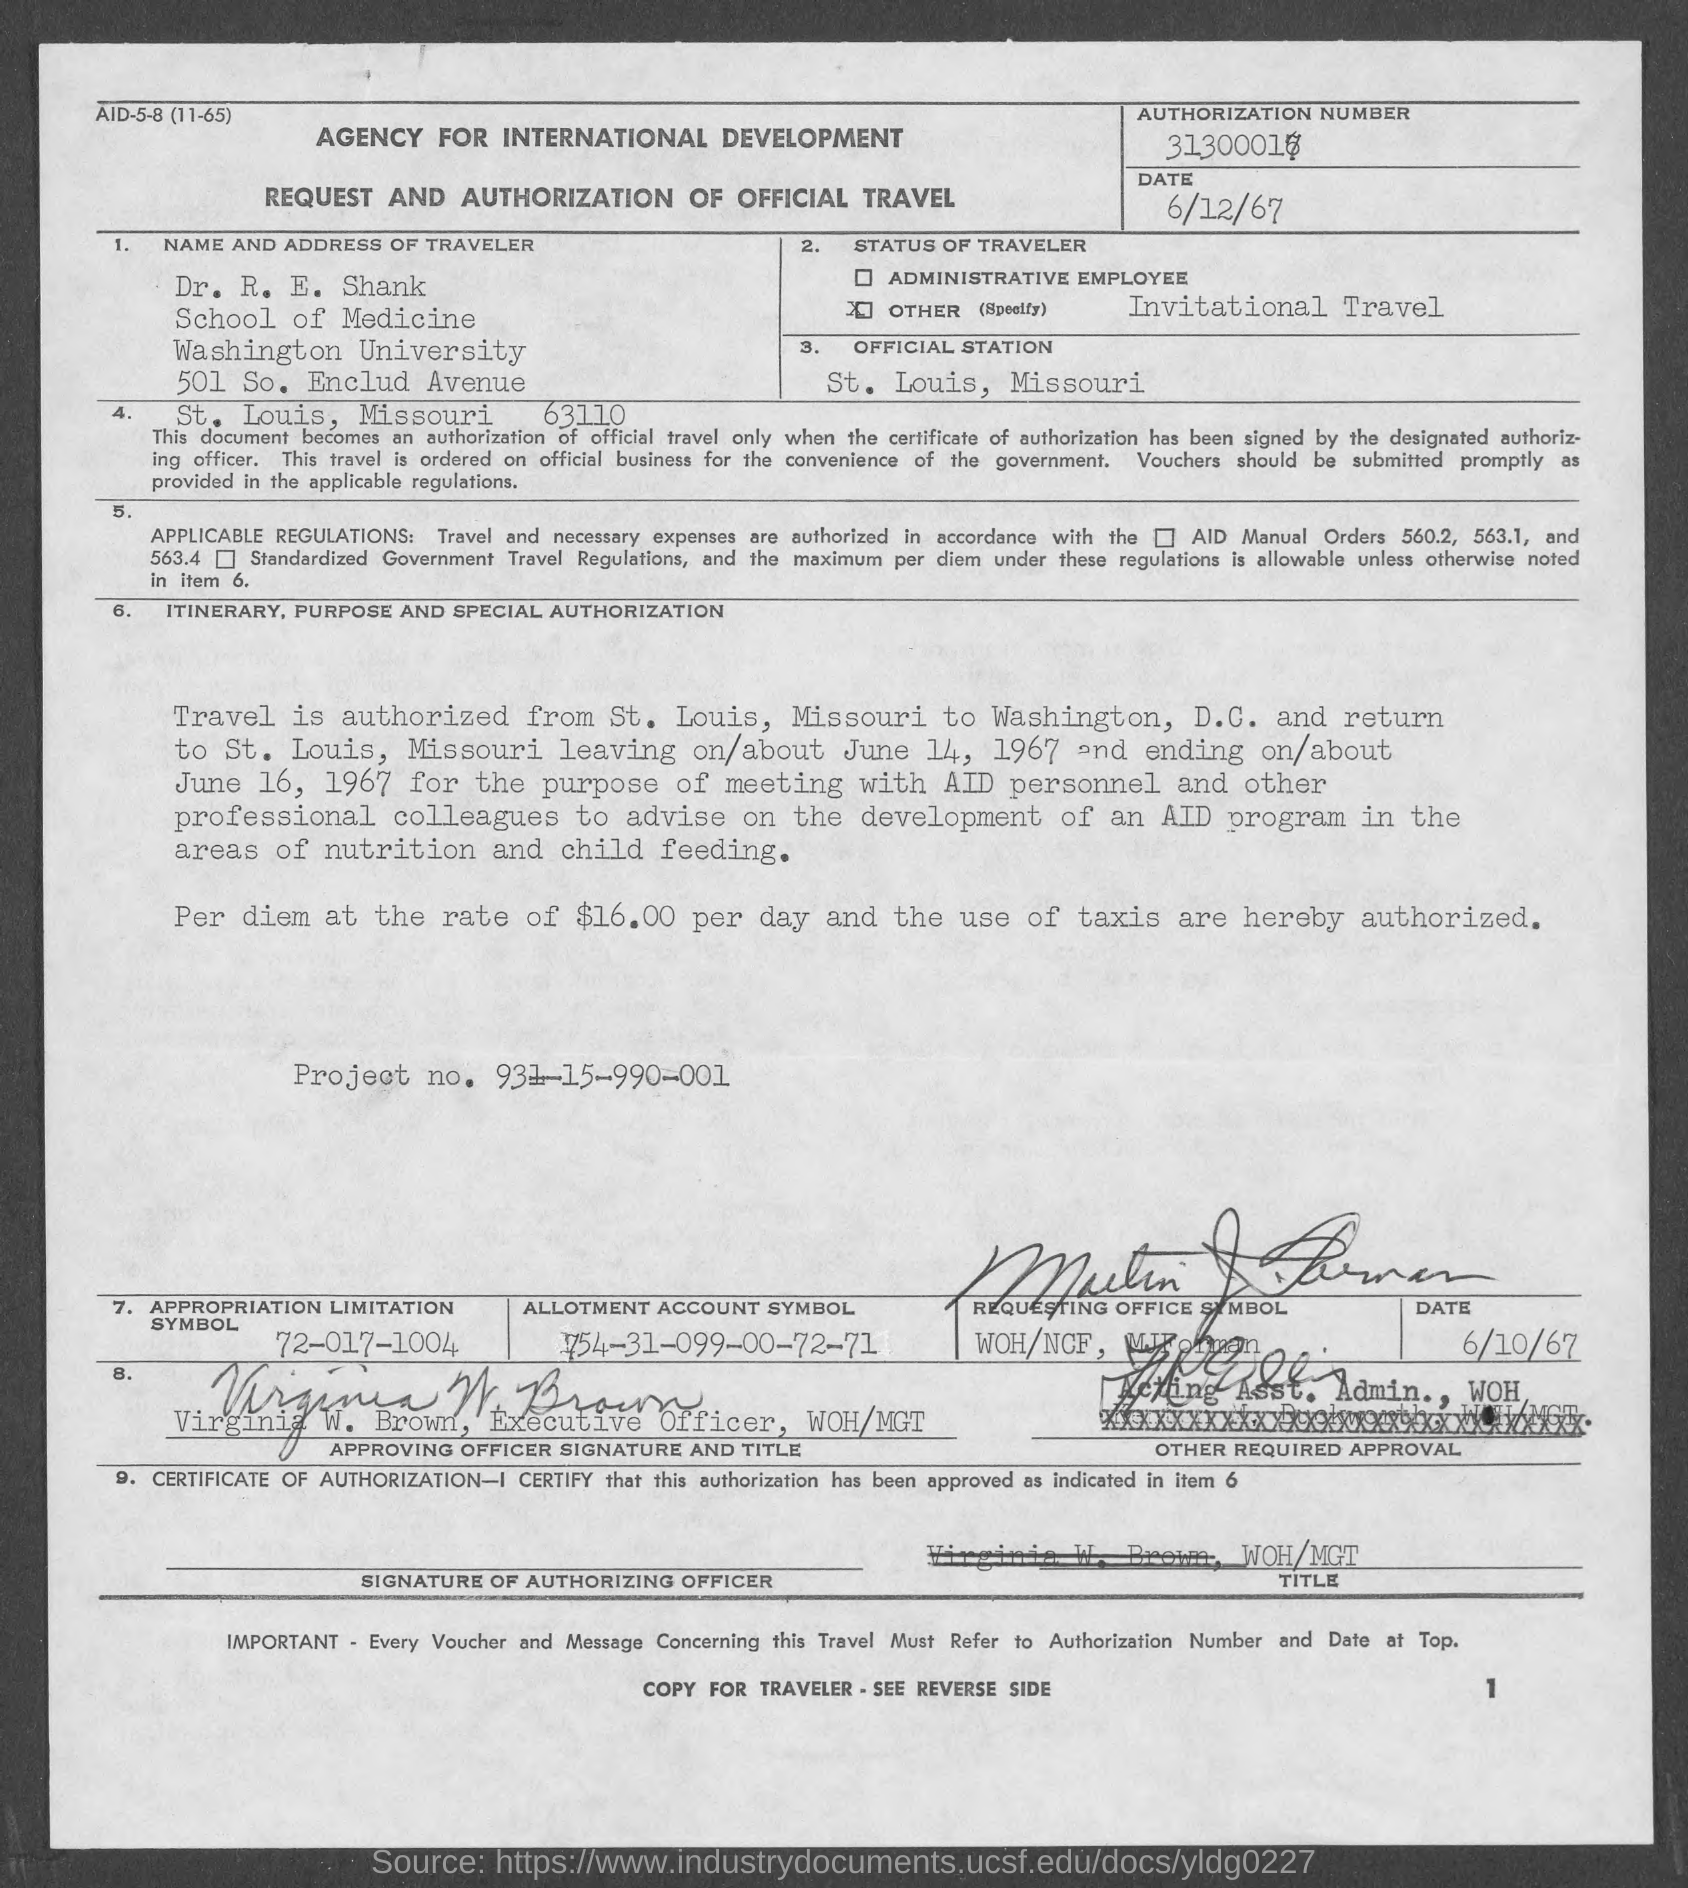List a handful of essential elements in this visual. The allotment account symbol is a unique identifier that represents a specific account, which was created on March 9th, 1754 and has a value of 00-72-71. The official station is St. Louis. The appropriation limitation symbol is 72-017-1004. The project number is 931-15-990-001. The status of a traveler is currently that of invitational travel. 